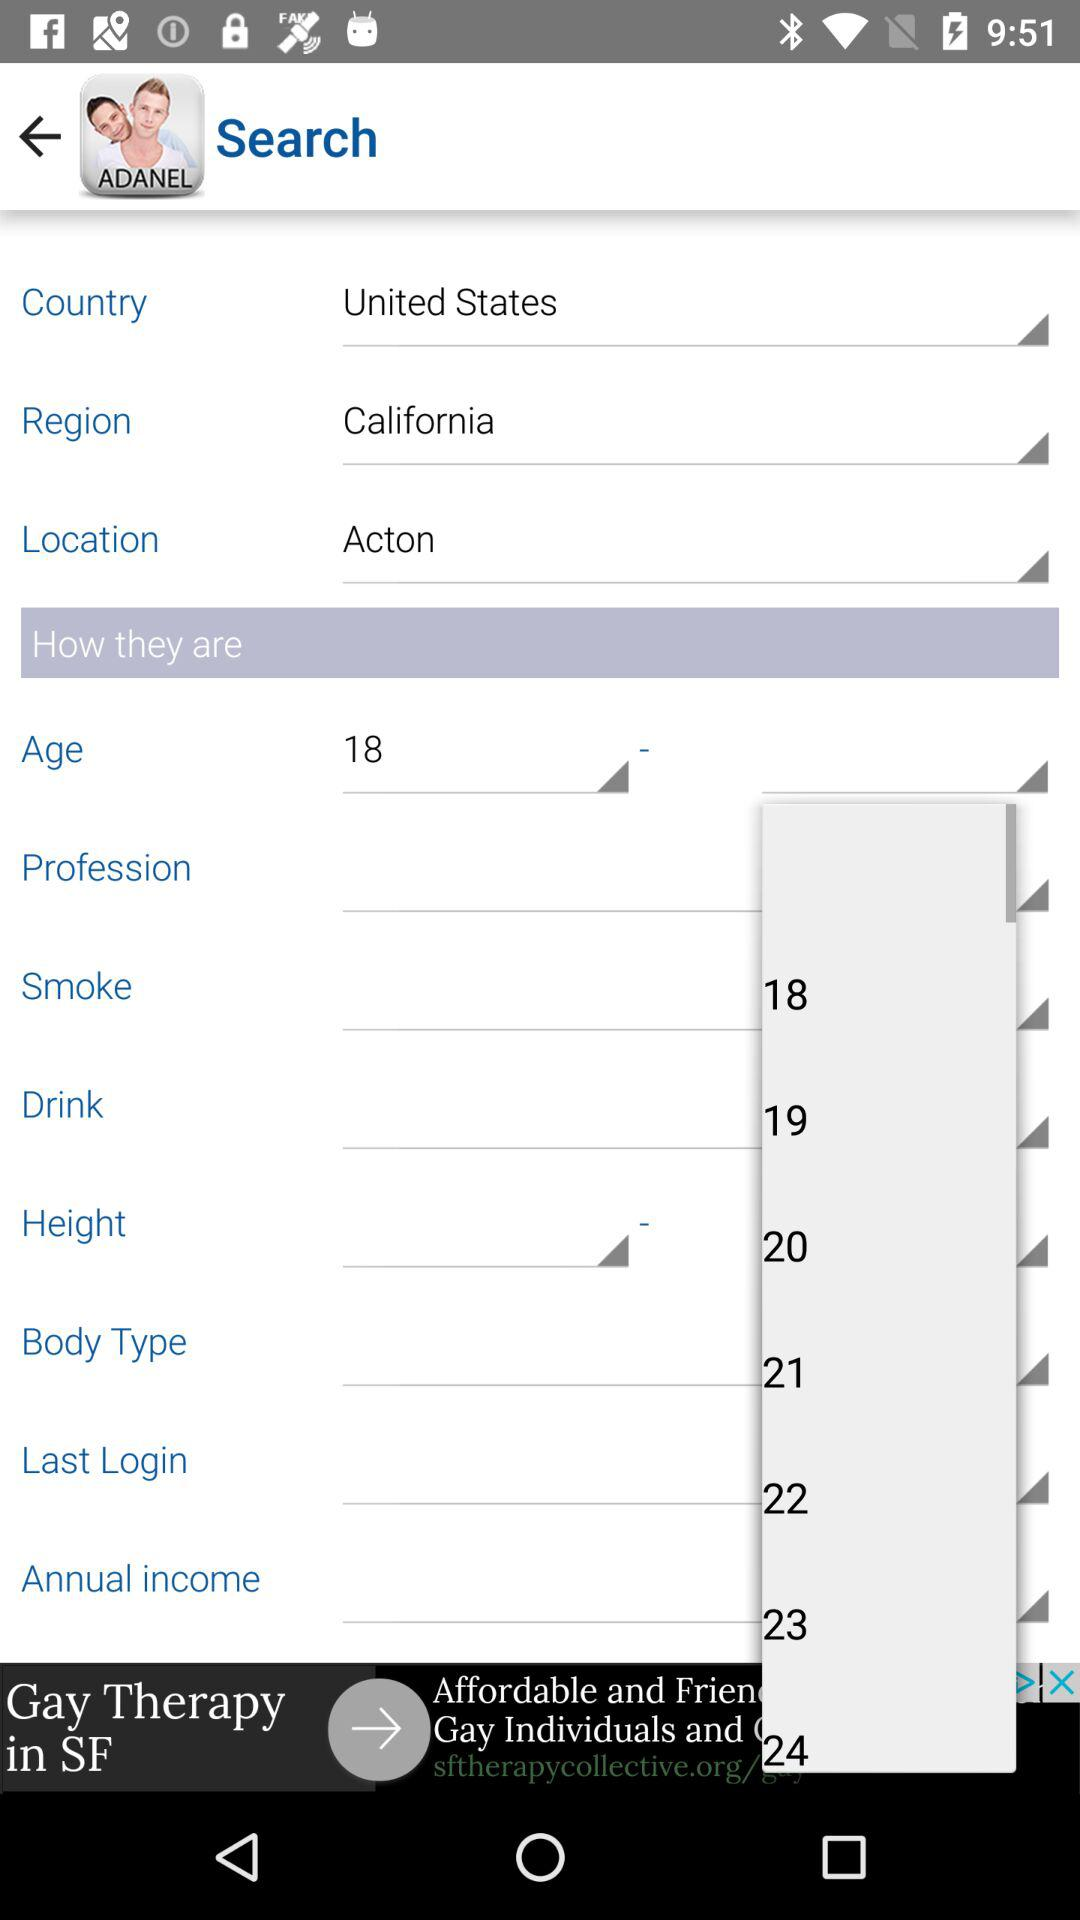What is the selected region? The selected region is California. 